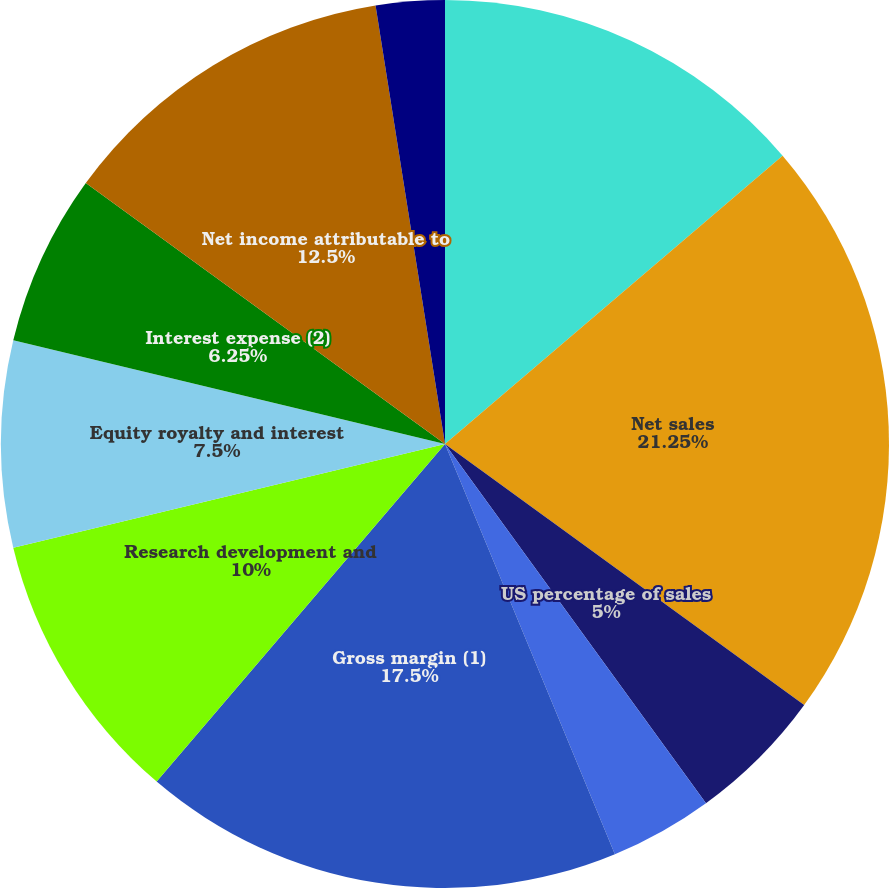<chart> <loc_0><loc_0><loc_500><loc_500><pie_chart><fcel>In millions except per share<fcel>Net sales<fcel>US percentage of sales<fcel>Non-US percentage of sales<fcel>Gross margin (1)<fcel>Research development and<fcel>Equity royalty and interest<fcel>Interest expense (2)<fcel>Net income attributable to<fcel>Basic<nl><fcel>13.75%<fcel>21.25%<fcel>5.0%<fcel>3.75%<fcel>17.5%<fcel>10.0%<fcel>7.5%<fcel>6.25%<fcel>12.5%<fcel>2.5%<nl></chart> 